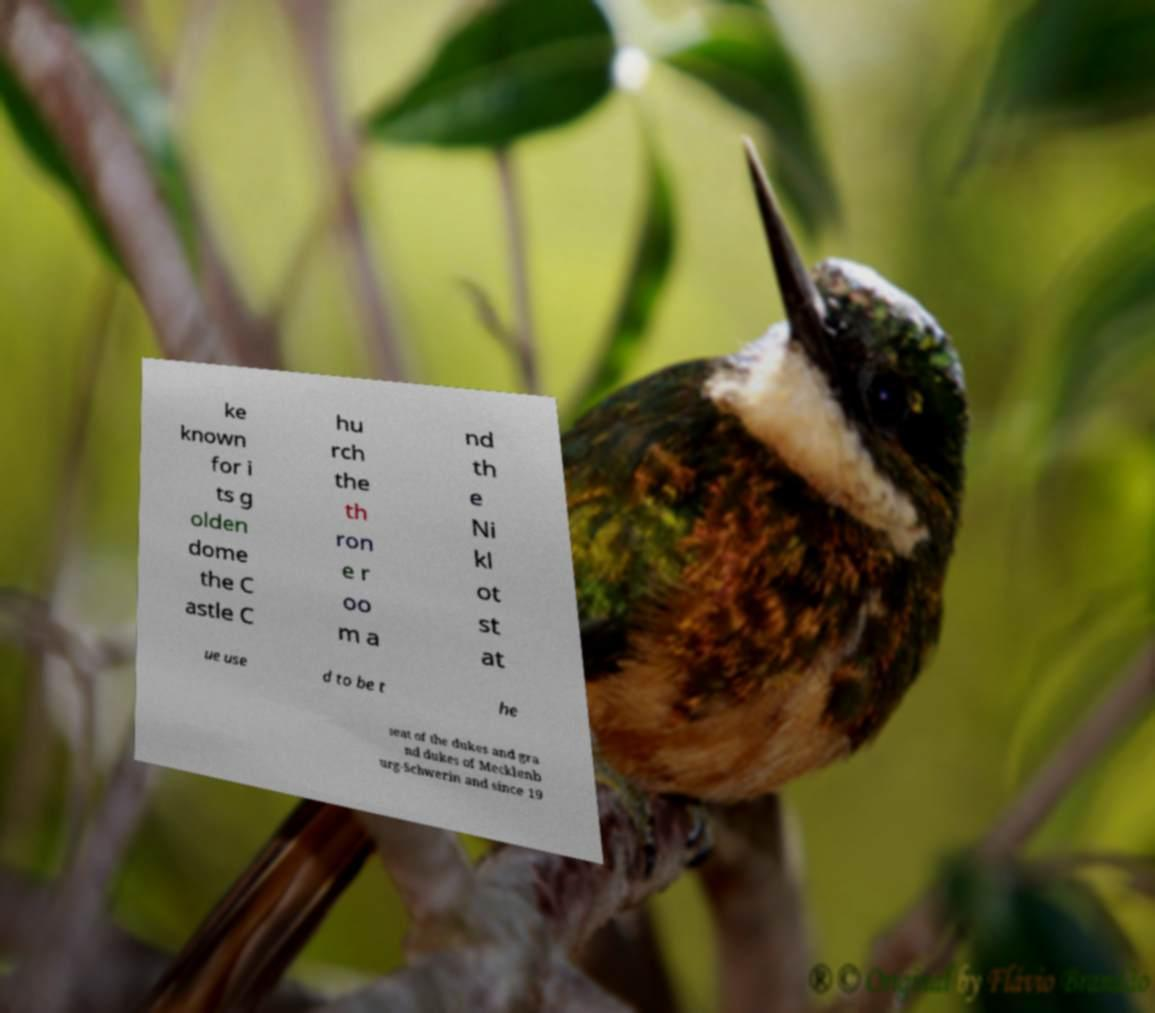Could you assist in decoding the text presented in this image and type it out clearly? ke known for i ts g olden dome the C astle C hu rch the th ron e r oo m a nd th e Ni kl ot st at ue use d to be t he seat of the dukes and gra nd dukes of Mecklenb urg-Schwerin and since 19 